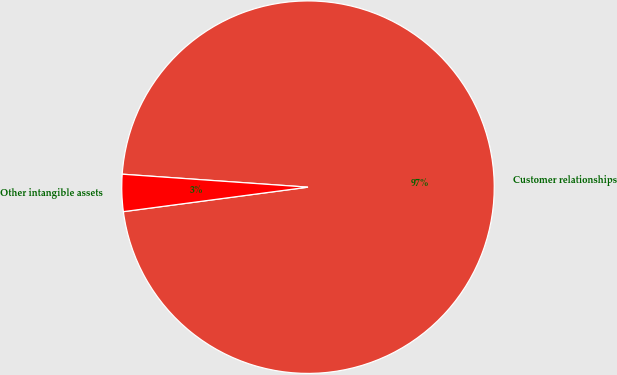Convert chart. <chart><loc_0><loc_0><loc_500><loc_500><pie_chart><fcel>Customer relationships<fcel>Other intangible assets<nl><fcel>96.79%<fcel>3.21%<nl></chart> 